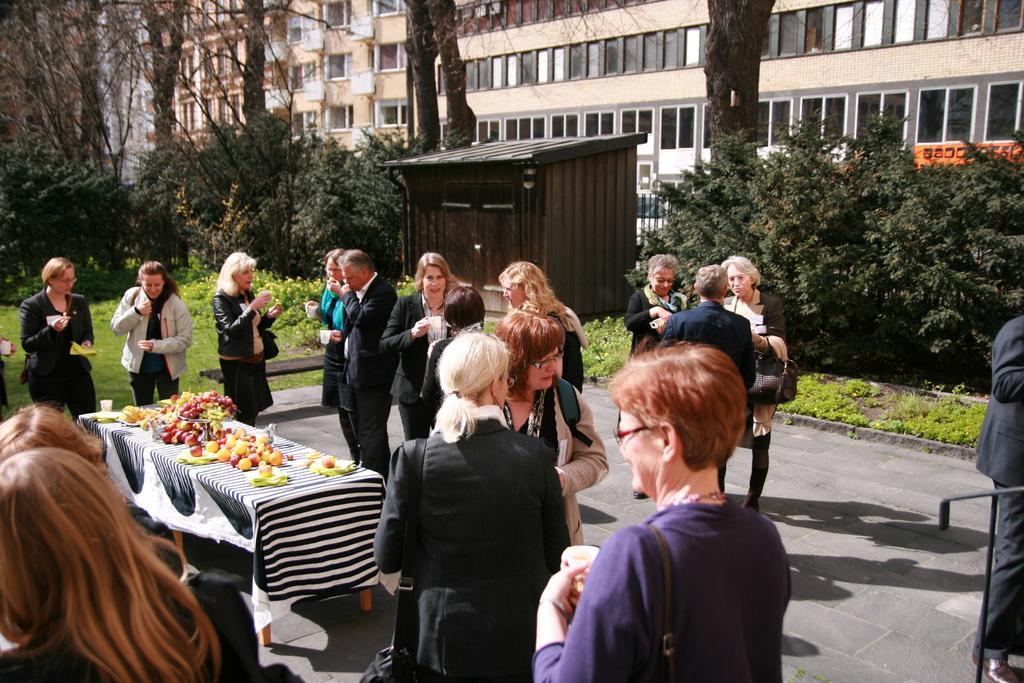Can you describe this image briefly? Here men and women are standing, there are buildings with the windows, these are trees, there are fruits on the table. 